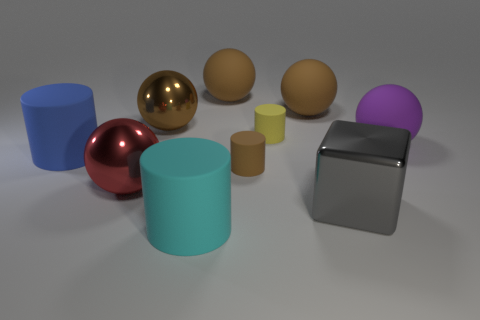What is the size of the metal ball in front of the brown rubber thing that is in front of the metal thing that is behind the purple thing?
Make the answer very short. Large. There is a purple ball; are there any tiny yellow objects on the right side of it?
Offer a very short reply. No. There is a purple thing that is the same material as the brown cylinder; what is its size?
Your answer should be very brief. Large. What number of small yellow objects have the same shape as the large gray metallic thing?
Keep it short and to the point. 0. Are the cyan thing and the big cylinder that is to the left of the big brown shiny sphere made of the same material?
Your answer should be very brief. Yes. Is the number of large metallic things that are to the left of the big blue matte cylinder greater than the number of yellow objects?
Make the answer very short. No. Are there any large red spheres made of the same material as the blue object?
Give a very brief answer. No. Is the material of the small thing in front of the blue cylinder the same as the large cylinder behind the big cyan object?
Offer a very short reply. Yes. Is the number of large red balls in front of the big cyan rubber cylinder the same as the number of rubber things behind the gray shiny thing?
Give a very brief answer. No. There is a block that is the same size as the blue matte object; what is its color?
Your response must be concise. Gray. 